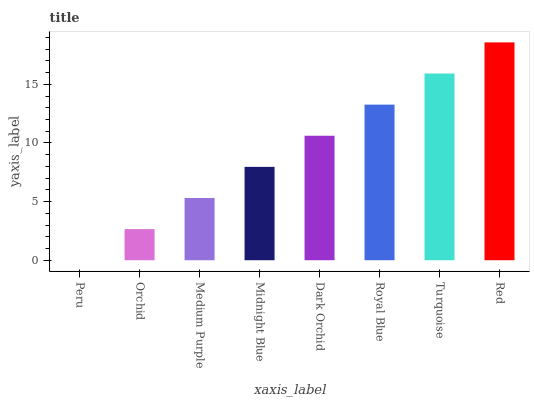Is Orchid the minimum?
Answer yes or no. No. Is Orchid the maximum?
Answer yes or no. No. Is Orchid greater than Peru?
Answer yes or no. Yes. Is Peru less than Orchid?
Answer yes or no. Yes. Is Peru greater than Orchid?
Answer yes or no. No. Is Orchid less than Peru?
Answer yes or no. No. Is Dark Orchid the high median?
Answer yes or no. Yes. Is Midnight Blue the low median?
Answer yes or no. Yes. Is Orchid the high median?
Answer yes or no. No. Is Orchid the low median?
Answer yes or no. No. 